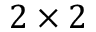<formula> <loc_0><loc_0><loc_500><loc_500>2 \times 2</formula> 